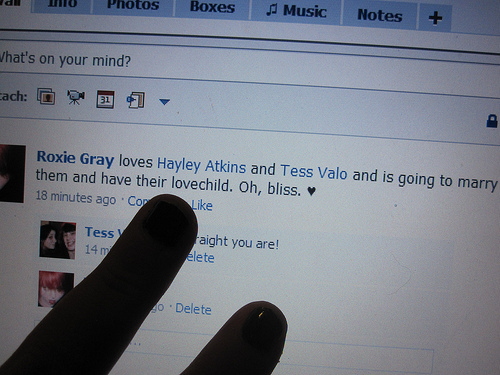<image>
Is there a monitor above the finger? No. The monitor is not positioned above the finger. The vertical arrangement shows a different relationship. 